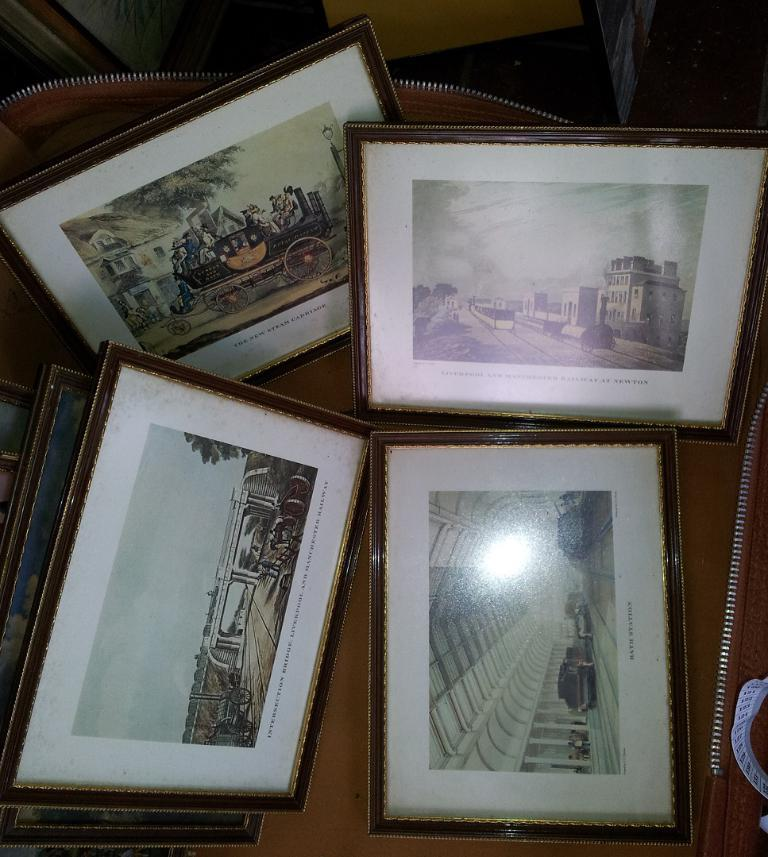What can be seen in the image that holds the photo frames? The photo frames are on an object, but the facts do not specify what that object is. What is depicted in the paintings within the photo frames? The paintings in the photo frames contain images of people, the sky, trees, and other things. Can you describe the content of the paintings in more detail? The paintings in the photo frames contain paintings of people, the sky, trees, and other things, but the facts do not specify what those other things are. Where is the army located in the image? There is no mention of an army in the image or the provided facts. Is there a volcano visible in the image? There is no mention of a volcano in the image or the provided facts. 